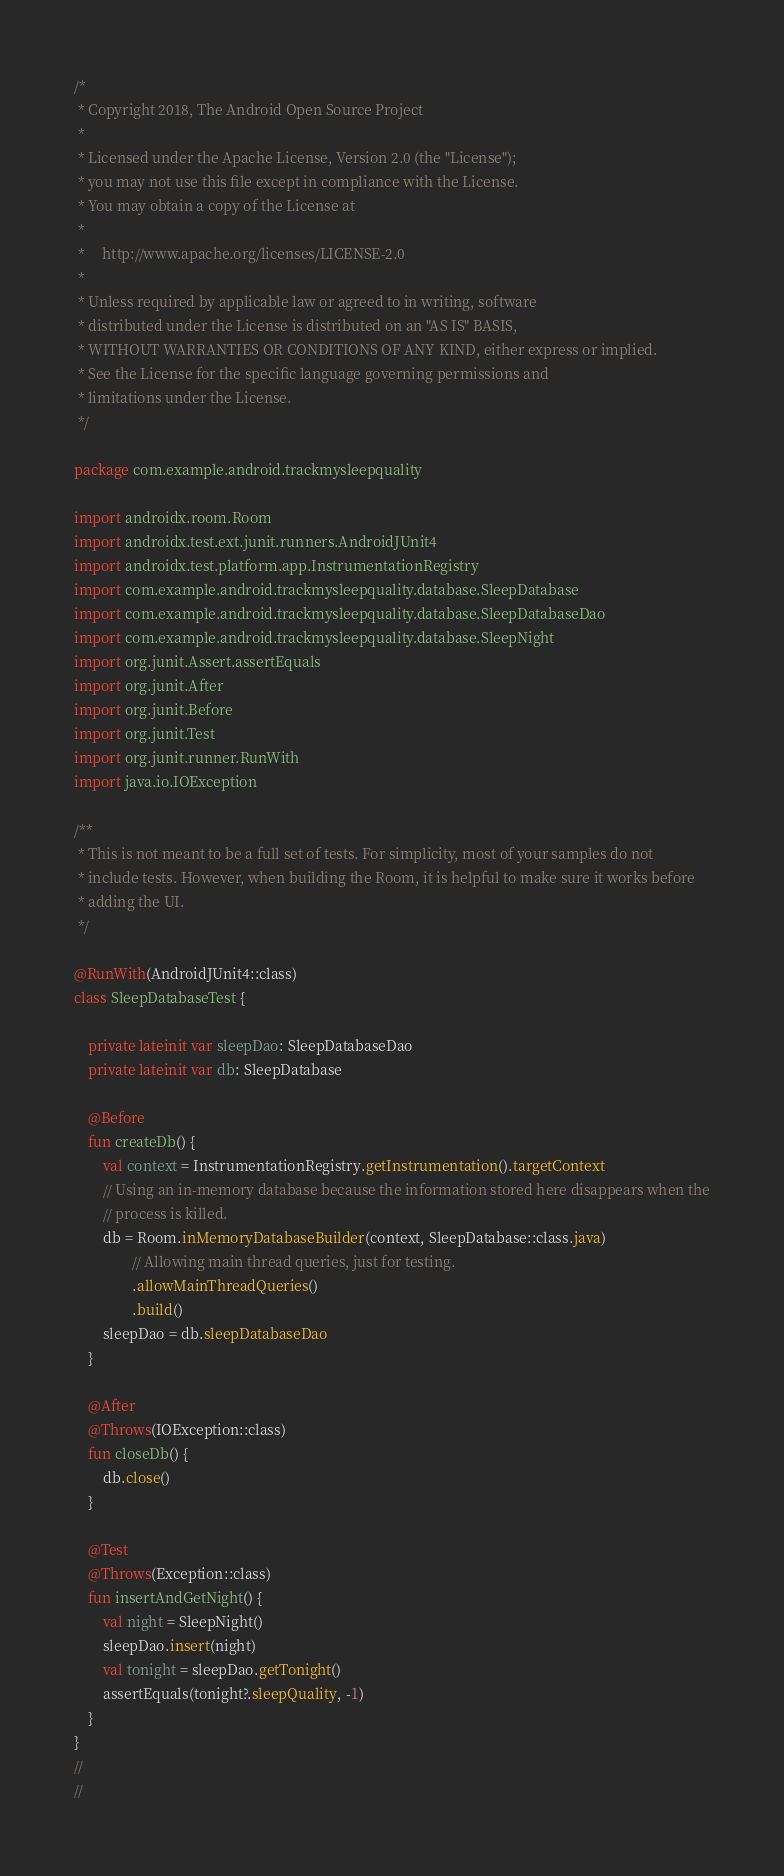Convert code to text. <code><loc_0><loc_0><loc_500><loc_500><_Kotlin_>/*
 * Copyright 2018, The Android Open Source Project
 *
 * Licensed under the Apache License, Version 2.0 (the "License");
 * you may not use this file except in compliance with the License.
 * You may obtain a copy of the License at
 *
 *     http://www.apache.org/licenses/LICENSE-2.0
 *
 * Unless required by applicable law or agreed to in writing, software
 * distributed under the License is distributed on an "AS IS" BASIS,
 * WITHOUT WARRANTIES OR CONDITIONS OF ANY KIND, either express or implied.
 * See the License for the specific language governing permissions and
 * limitations under the License.
 */

package com.example.android.trackmysleepquality

import androidx.room.Room
import androidx.test.ext.junit.runners.AndroidJUnit4
import androidx.test.platform.app.InstrumentationRegistry
import com.example.android.trackmysleepquality.database.SleepDatabase
import com.example.android.trackmysleepquality.database.SleepDatabaseDao
import com.example.android.trackmysleepquality.database.SleepNight
import org.junit.Assert.assertEquals
import org.junit.After
import org.junit.Before
import org.junit.Test
import org.junit.runner.RunWith
import java.io.IOException

/**
 * This is not meant to be a full set of tests. For simplicity, most of your samples do not
 * include tests. However, when building the Room, it is helpful to make sure it works before
 * adding the UI.
 */

@RunWith(AndroidJUnit4::class)
class SleepDatabaseTest {

    private lateinit var sleepDao: SleepDatabaseDao
    private lateinit var db: SleepDatabase

    @Before
    fun createDb() {
        val context = InstrumentationRegistry.getInstrumentation().targetContext
        // Using an in-memory database because the information stored here disappears when the
        // process is killed.
        db = Room.inMemoryDatabaseBuilder(context, SleepDatabase::class.java)
                // Allowing main thread queries, just for testing.
                .allowMainThreadQueries()
                .build()
        sleepDao = db.sleepDatabaseDao
    }

    @After
    @Throws(IOException::class)
    fun closeDb() {
        db.close()
    }

    @Test
    @Throws(Exception::class)
    fun insertAndGetNight() {
        val night = SleepNight()
        sleepDao.insert(night)
        val tonight = sleepDao.getTonight()
        assertEquals(tonight?.sleepQuality, -1)
    }
}
//
//</code> 